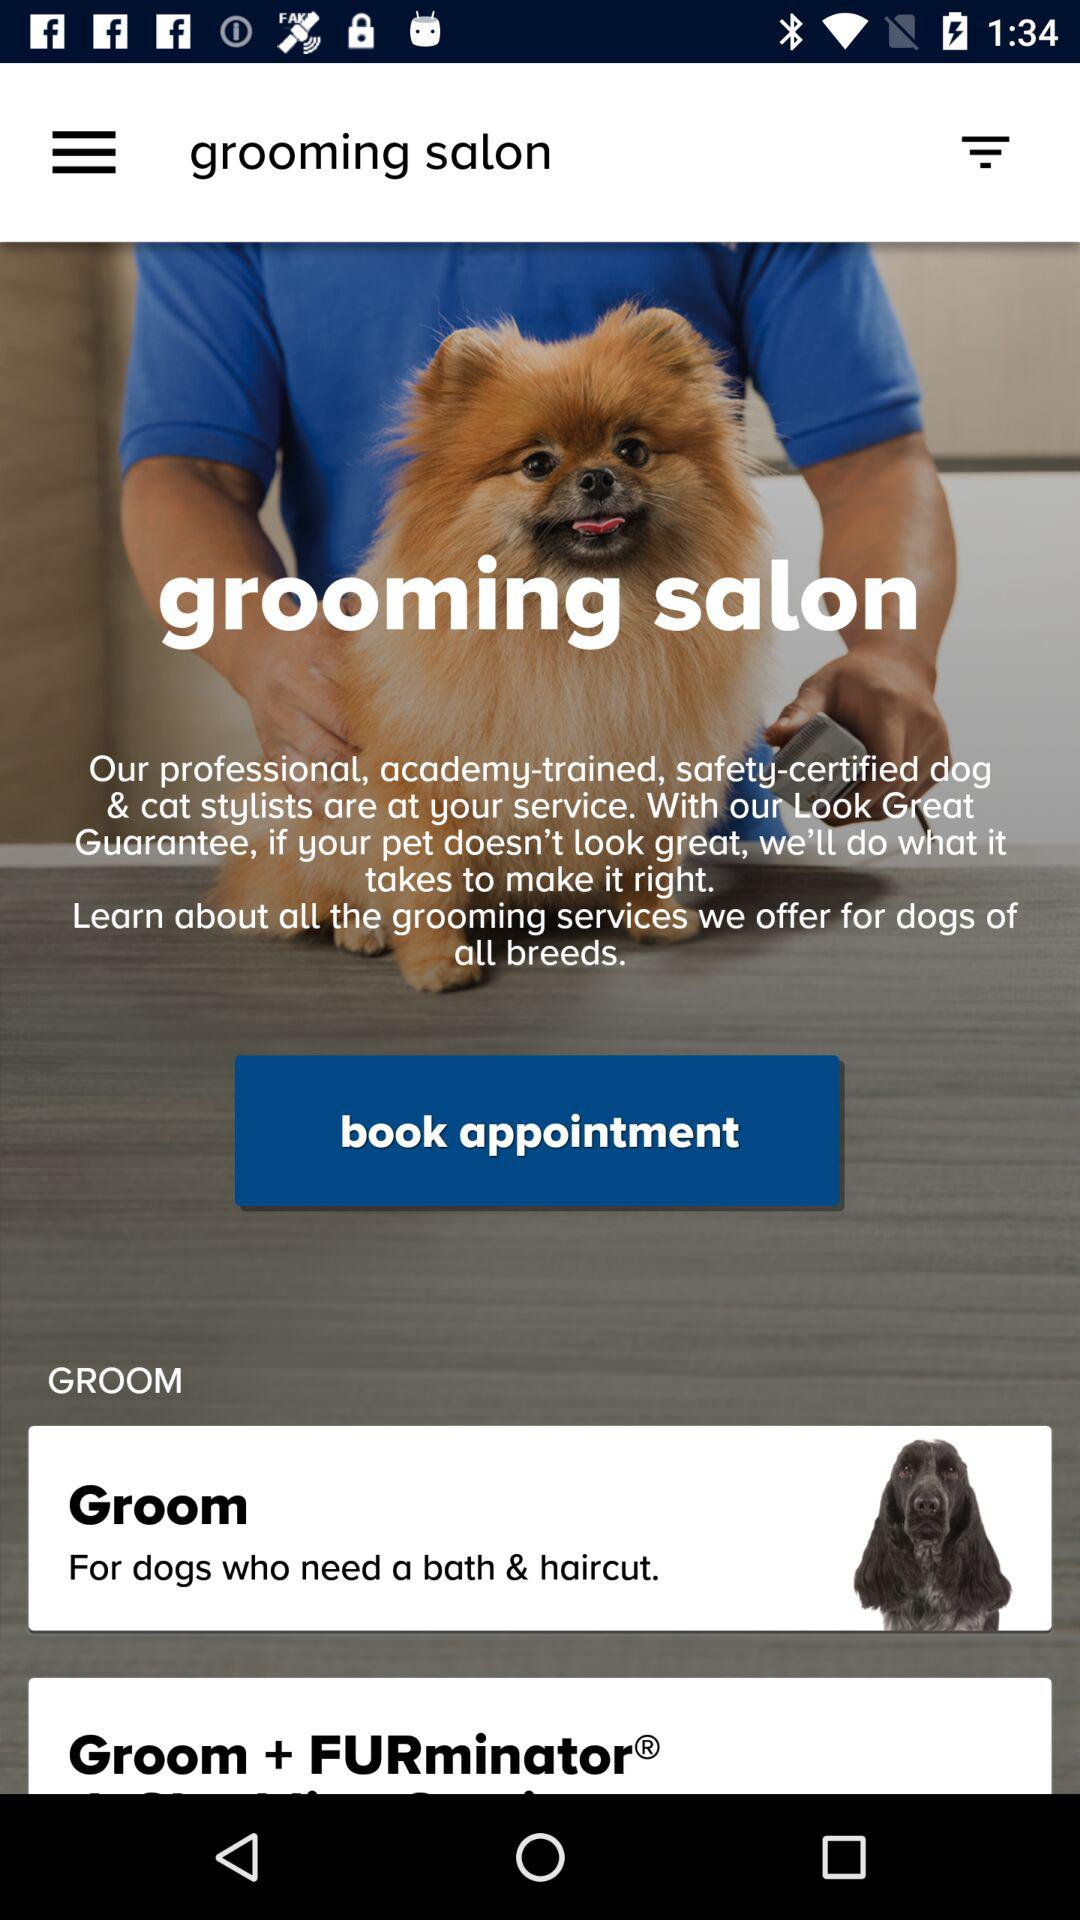How many grooming services are offered for dogs?
Answer the question using a single word or phrase. 2 